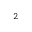Convert formula to latex. <formula><loc_0><loc_0><loc_500><loc_500>{ } ^ { 2 }</formula> 